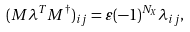Convert formula to latex. <formula><loc_0><loc_0><loc_500><loc_500>( M \lambda ^ { T } M ^ { \dagger } ) _ { i j } = \varepsilon ( - 1 ) ^ { N _ { X } } \lambda _ { i j } ,</formula> 